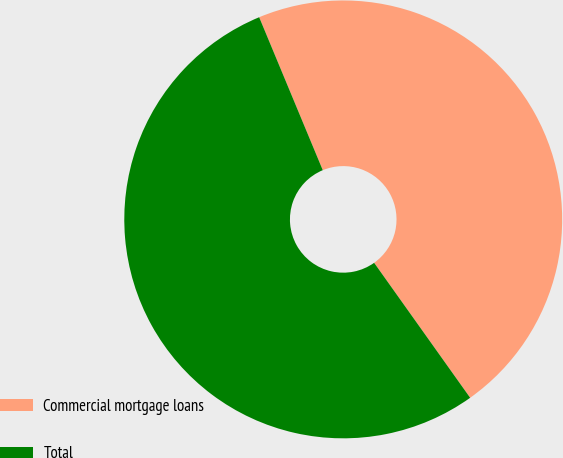Convert chart. <chart><loc_0><loc_0><loc_500><loc_500><pie_chart><fcel>Commercial mortgage loans<fcel>Total<nl><fcel>46.43%<fcel>53.57%<nl></chart> 